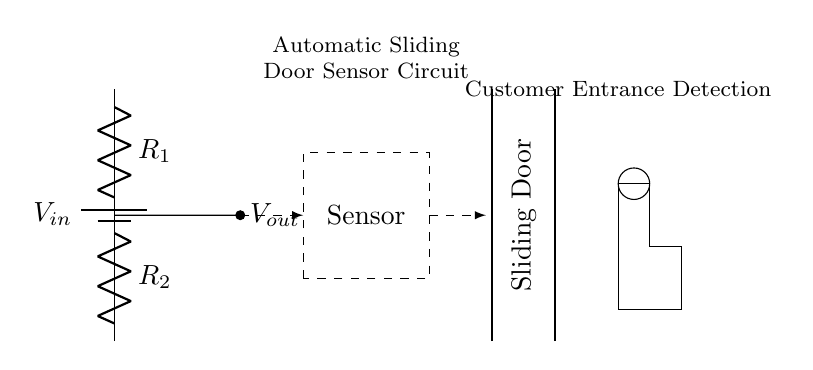What is the type of sensor used in this circuit? The rectangle labeled "Sensor" indicates the type used, which is a presence or motion sensor for customer entrance detection.
Answer: Sensor What are the resistances in the voltage divider? The circuit has two resistors labeled as R1 and R2. These are part of the voltage divider configuration, which divides the input voltage.
Answer: R1, R2 What is the purpose of the voltage divider in this circuit? The voltage divider's purpose is to lower the input voltage to a desired level for the sensor to operate effectively in detecting presence without damaging the sensor.
Answer: Lower voltage for sensor Where is the output voltage taken from in the circuit? The output voltage is taken from the node between the two resistors, specifically connected to the sensor, showing it as Vout.
Answer: From the node between R1 and R2 If R1 is 1 kohm and R2 is 2 kohm, what is the voltage at Vout if Vin is 6V? The voltage at Vout can be calculated using the voltage divider formula Vout = Vin * (R2 / (R1 + R2)), which gives us 4V when Vin is 6V.
Answer: 4V What happens when a person approaches the sensor? When a person approaches, the sensor detects motion, likely resulting in a signal being sent to trigger the door mechanism through the output voltage.
Answer: Door opens What is the role of the sliding door shown in the circuit? The sliding door implements the action based on the detection of a person by the sensor, facilitating customer entrance.
Answer: Customer entrance 